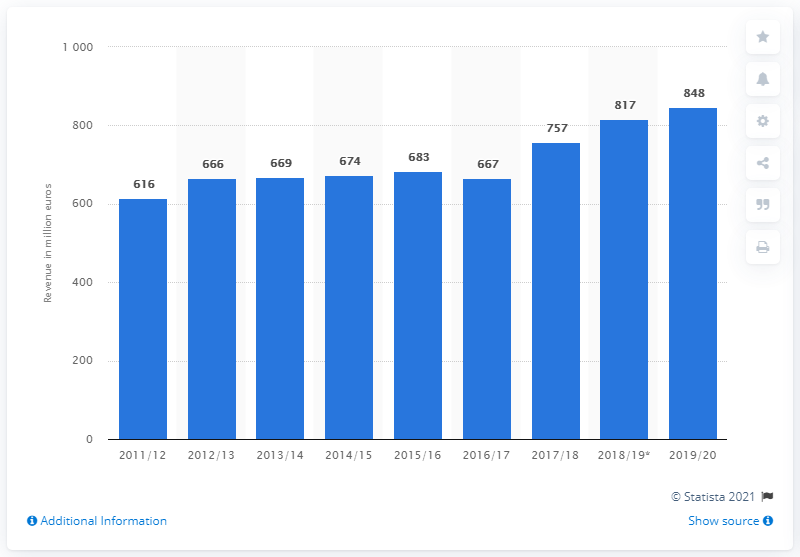Outline some significant characteristics in this image. In the 2019/20 fiscal year, the Otto Group subsidiary generated revenue of 848 million euros. The revenue of the Otto Group subsidiary in the previous year was 817... 